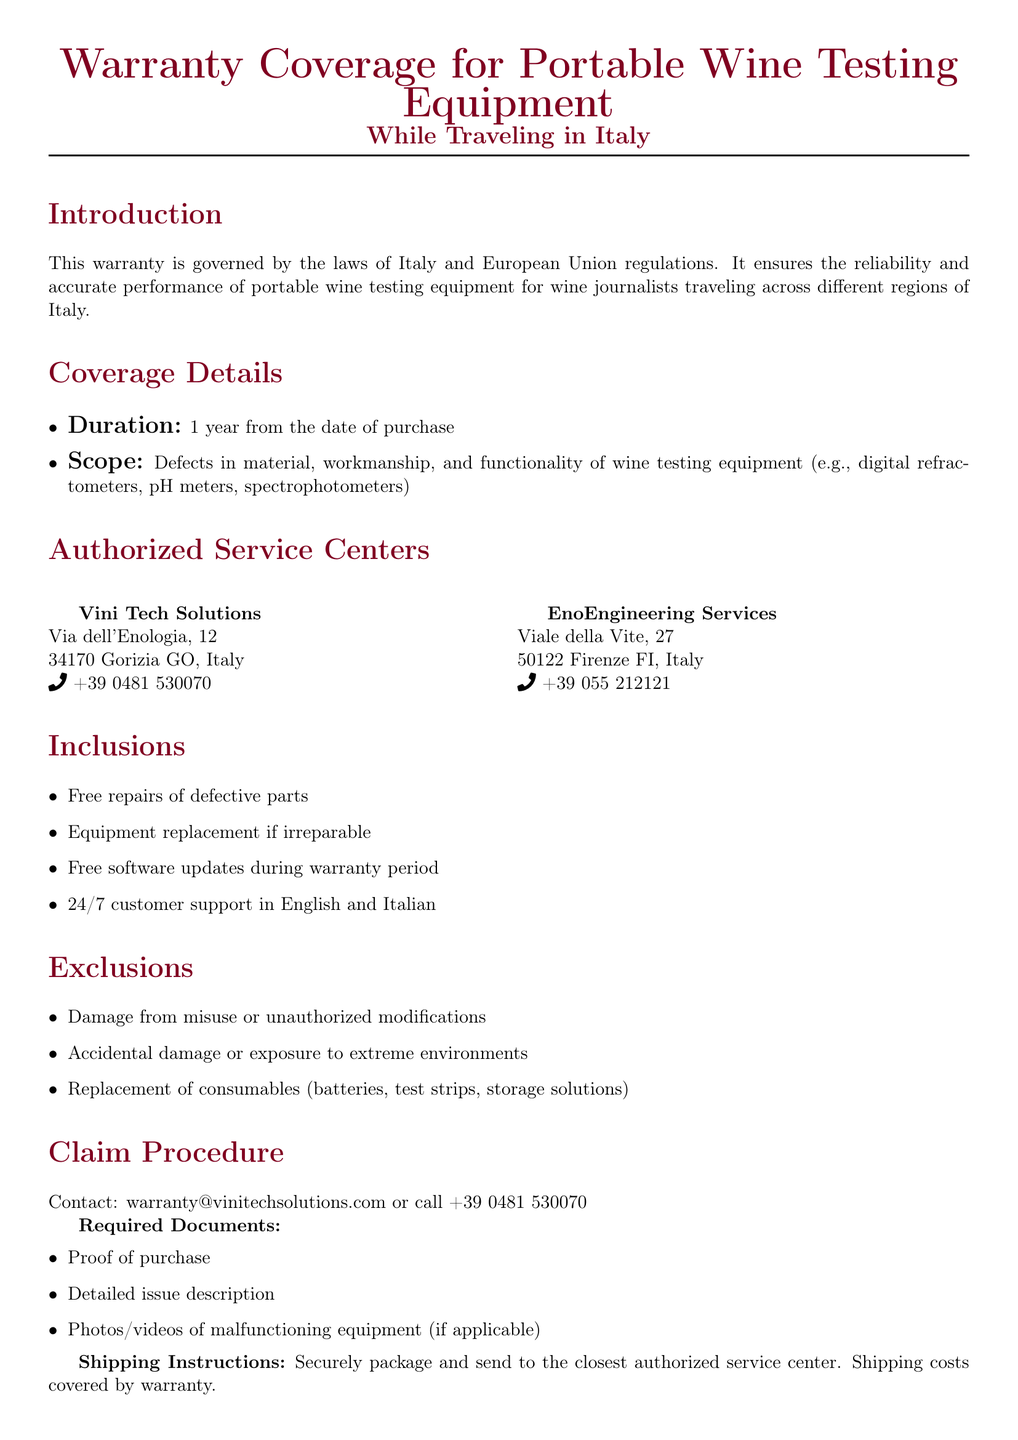What is the duration of the warranty? The warranty duration is stated in the document as 1 year from the date of purchase.
Answer: 1 year What types of defects are covered under the warranty? The document lists defects in material, workmanship, and functionality of portable wine testing equipment as covered issues.
Answer: Defects in material, workmanship, and functionality Name one authorized service center mentioned in the document. The document provides the names and locations of two authorized service centers, one of which can be used as an example.
Answer: Vini Tech Solutions What is excluded from the warranty coverage? The document specifies various exclusions; one notable exclusion is damage from misuse or unauthorized modifications.
Answer: Damage from misuse or unauthorized modifications What is required to make a warranty claim? The document lists several required documents for a warranty claim, including proof of purchase as a central element.
Answer: Proof of purchase How can I contact for claiming the warranty? The document mentions a specific email address and phone number for warranty claims.
Answer: warranty@vinitechsolutions.com What can I expect in case of irreparable equipment? The warranty outlines that equipment replacement will occur if the equipment is deemed irreparable.
Answer: Equipment replacement Which languages is customer support available in? The document states that customer support is available in both English and Italian.
Answer: English and Italian What should be avoided to ensure warranty validity? The document advises avoiding exposure to extreme temperatures and humidity to maintain warranty validity.
Answer: Exposure to extreme temperatures and humidity 